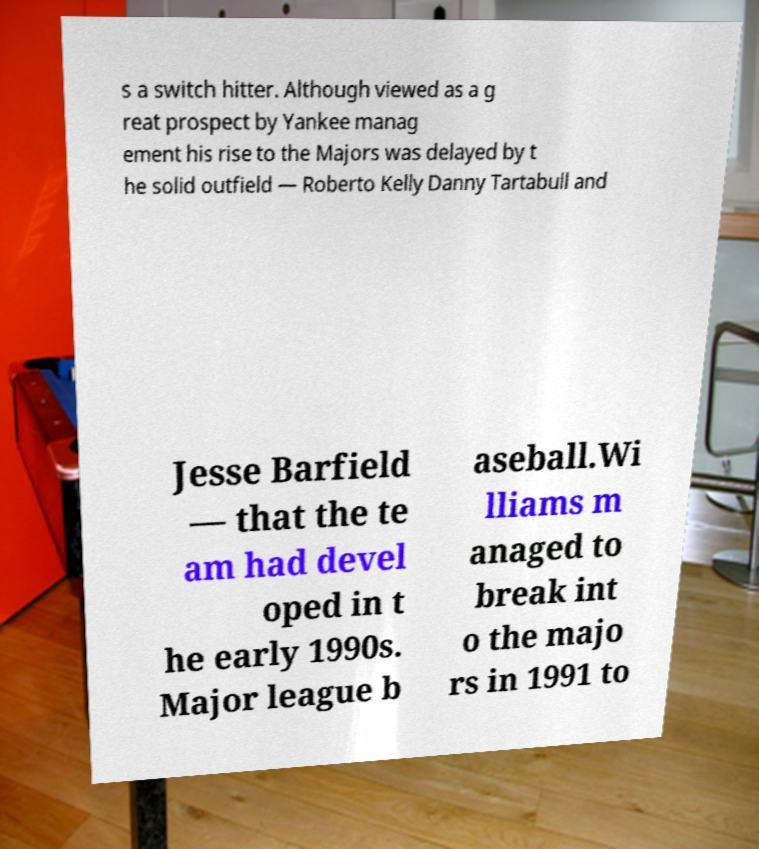Could you extract and type out the text from this image? s a switch hitter. Although viewed as a g reat prospect by Yankee manag ement his rise to the Majors was delayed by t he solid outfield — Roberto Kelly Danny Tartabull and Jesse Barfield — that the te am had devel oped in t he early 1990s. Major league b aseball.Wi lliams m anaged to break int o the majo rs in 1991 to 